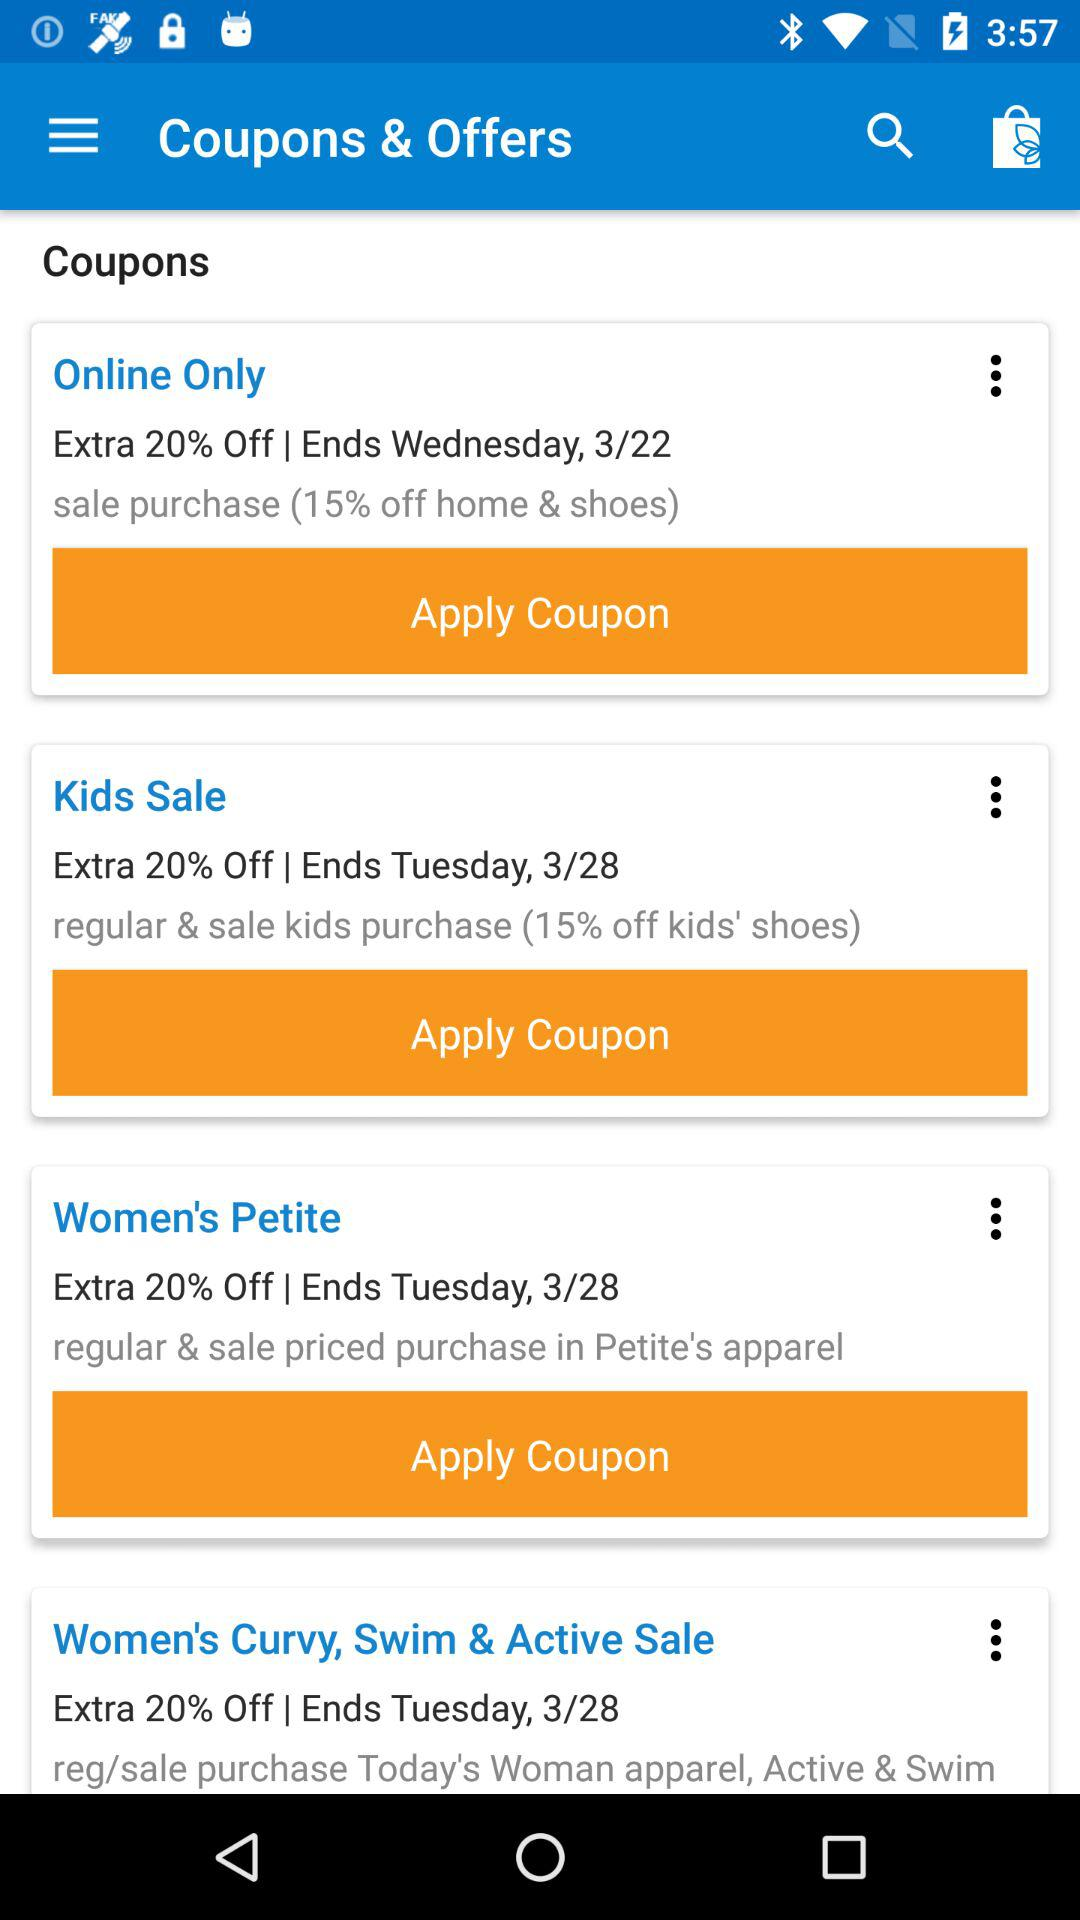How many coupons have an expiration date of Tuesday, 3/28?
Answer the question using a single word or phrase. 3 